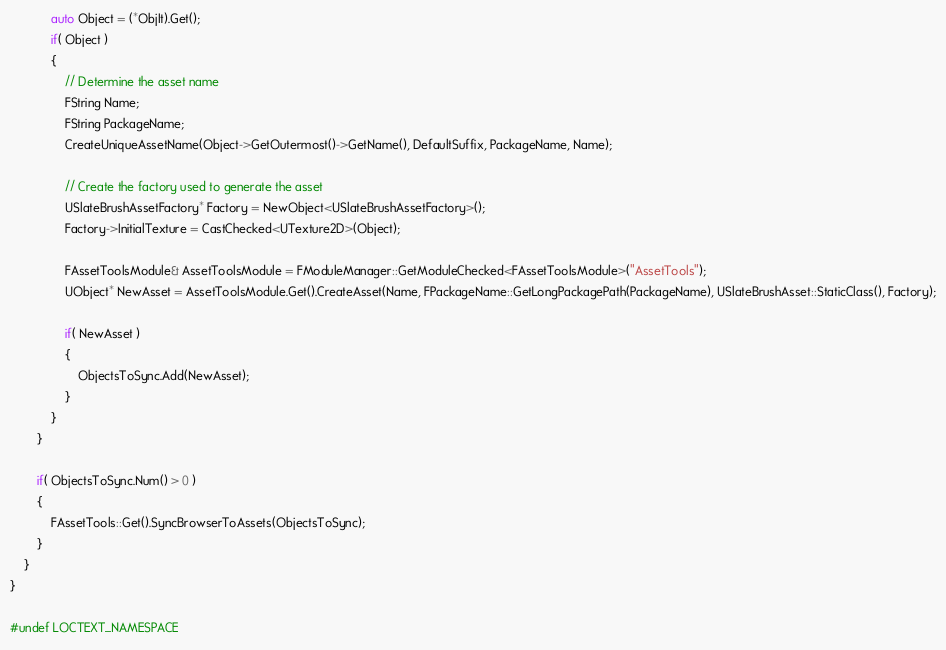Convert code to text. <code><loc_0><loc_0><loc_500><loc_500><_C++_>			auto Object = (*ObjIt).Get();
			if( Object )
			{
				// Determine the asset name
				FString Name;
				FString PackageName;
				CreateUniqueAssetName(Object->GetOutermost()->GetName(), DefaultSuffix, PackageName, Name);

				// Create the factory used to generate the asset
				USlateBrushAssetFactory* Factory = NewObject<USlateBrushAssetFactory>();
				Factory->InitialTexture = CastChecked<UTexture2D>(Object);

				FAssetToolsModule& AssetToolsModule = FModuleManager::GetModuleChecked<FAssetToolsModule>("AssetTools");
				UObject* NewAsset = AssetToolsModule.Get().CreateAsset(Name, FPackageName::GetLongPackagePath(PackageName), USlateBrushAsset::StaticClass(), Factory);

				if( NewAsset )
				{
					ObjectsToSync.Add(NewAsset);
				}
			}
		}

		if( ObjectsToSync.Num() > 0 )
		{
			FAssetTools::Get().SyncBrowserToAssets(ObjectsToSync);
		}
	}
}

#undef LOCTEXT_NAMESPACE</code> 